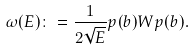<formula> <loc_0><loc_0><loc_500><loc_500>\omega ( E ) \colon = \frac { 1 } { 2 \sqrt { E } } p ( b ) W p ( b ) .</formula> 